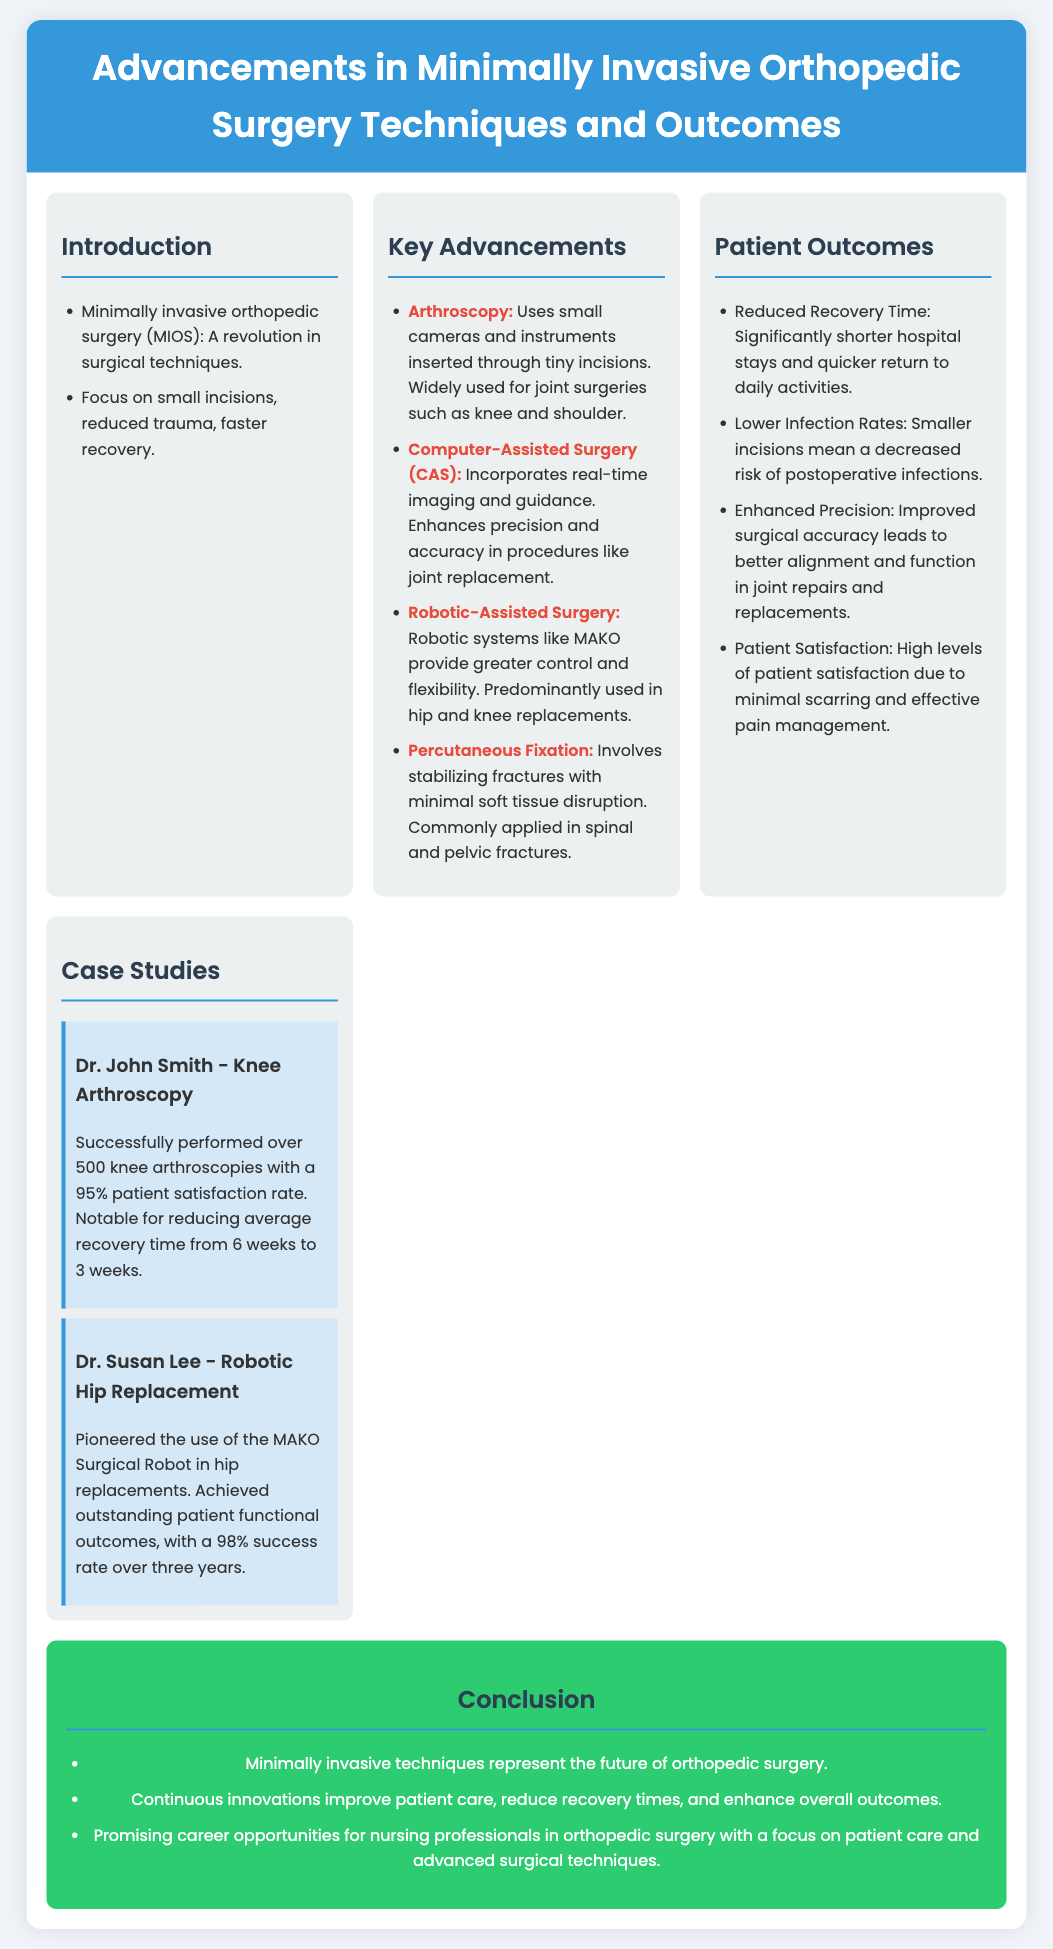What is MIOS? MIOS stands for Minimally Invasive Orthopedic Surgery, which refers to a revolution in surgical techniques that focus on small incisions and reduced trauma.
Answer: Minimally Invasive Orthopedic Surgery What technique uses small cameras in surgery? Arthroscopy is the technique that utilizes small cameras and instruments through tiny incisions.
Answer: Arthroscopy What is a key benefit of robotic-assisted surgery? Robotic-assisted surgery, like MAKO, provides greater control and flexibility, primarily in hip and knee replacements.
Answer: Greater control and flexibility What was the patient satisfaction rate of Dr. John Smith's knee arthroscopies? Dr. John Smith had a patient satisfaction rate of 95% after performing knee arthroscopies.
Answer: 95% How much did recovery time reduce by Dr. John Smith's technique? The average recovery time for Dr. John Smith's knee arthroscopies reduced from 6 weeks to 3 weeks.
Answer: 3 weeks What are the expected outcomes of minimally invasive techniques? Expected outcomes include reduced recovery times, enhanced precision, and lower infection rates.
Answer: Reduced recovery times How long is the success rate achievement period mentioned for Dr. Susan Lee's hip replacements? Dr. Susan Lee achieved a 98% success rate over three years in robotic hip replacements.
Answer: Three years What is the overall future of orthopedic surgery according to the conclusion? The conclusion indicates that minimally invasive techniques represent the future of orthopedic surgery.
Answer: The future of orthopedic surgery What does CAS stand for? CAS stands for Computer-Assisted Surgery, which enhances precision and accuracy in orthopedic procedures.
Answer: Computer-Assisted Surgery 